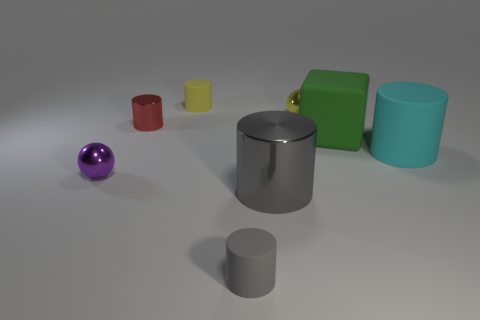There is a small metallic sphere that is behind the tiny cylinder left of the matte thing behind the yellow metal thing; what is its color?
Your answer should be compact. Yellow. How many matte objects are either yellow cylinders or tiny spheres?
Keep it short and to the point. 1. Is the number of big rubber things in front of the purple metal sphere greater than the number of tiny things in front of the large green rubber object?
Provide a short and direct response. No. What number of other objects are the same size as the green rubber object?
Your answer should be very brief. 2. There is a red cylinder left of the rubber cylinder right of the green block; what is its size?
Provide a succinct answer. Small. What number of big objects are green things or blue rubber things?
Your answer should be compact. 1. There is a ball to the left of the shiny cylinder that is on the right side of the matte cylinder that is behind the small yellow shiny sphere; what is its size?
Your response must be concise. Small. Is there any other thing of the same color as the tiny shiny cylinder?
Ensure brevity in your answer.  No. What material is the big cylinder on the left side of the big green matte cube that is on the right side of the red cylinder to the left of the big metal cylinder?
Provide a succinct answer. Metal. Is the shape of the red object the same as the cyan rubber object?
Provide a succinct answer. Yes. 